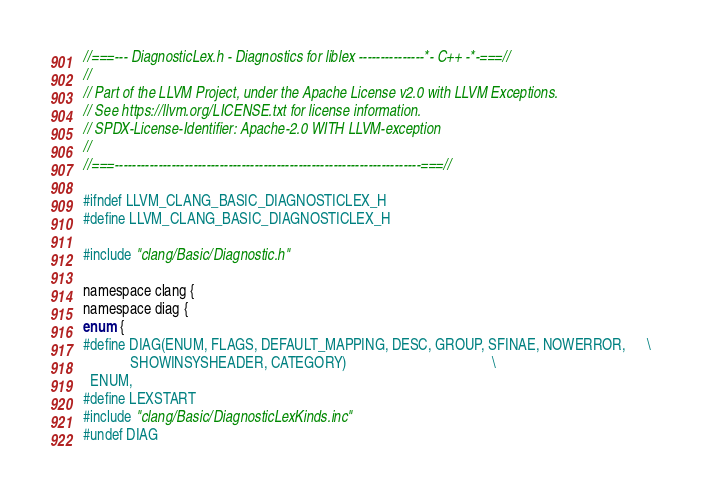Convert code to text. <code><loc_0><loc_0><loc_500><loc_500><_C_>//===--- DiagnosticLex.h - Diagnostics for liblex ---------------*- C++ -*-===//
//
// Part of the LLVM Project, under the Apache License v2.0 with LLVM Exceptions.
// See https://llvm.org/LICENSE.txt for license information.
// SPDX-License-Identifier: Apache-2.0 WITH LLVM-exception
//
//===----------------------------------------------------------------------===//

#ifndef LLVM_CLANG_BASIC_DIAGNOSTICLEX_H
#define LLVM_CLANG_BASIC_DIAGNOSTICLEX_H

#include "clang/Basic/Diagnostic.h"

namespace clang {
namespace diag {
enum {
#define DIAG(ENUM, FLAGS, DEFAULT_MAPPING, DESC, GROUP, SFINAE, NOWERROR,      \
             SHOWINSYSHEADER, CATEGORY)                                        \
  ENUM,
#define LEXSTART
#include "clang/Basic/DiagnosticLexKinds.inc"
#undef DIAG</code> 